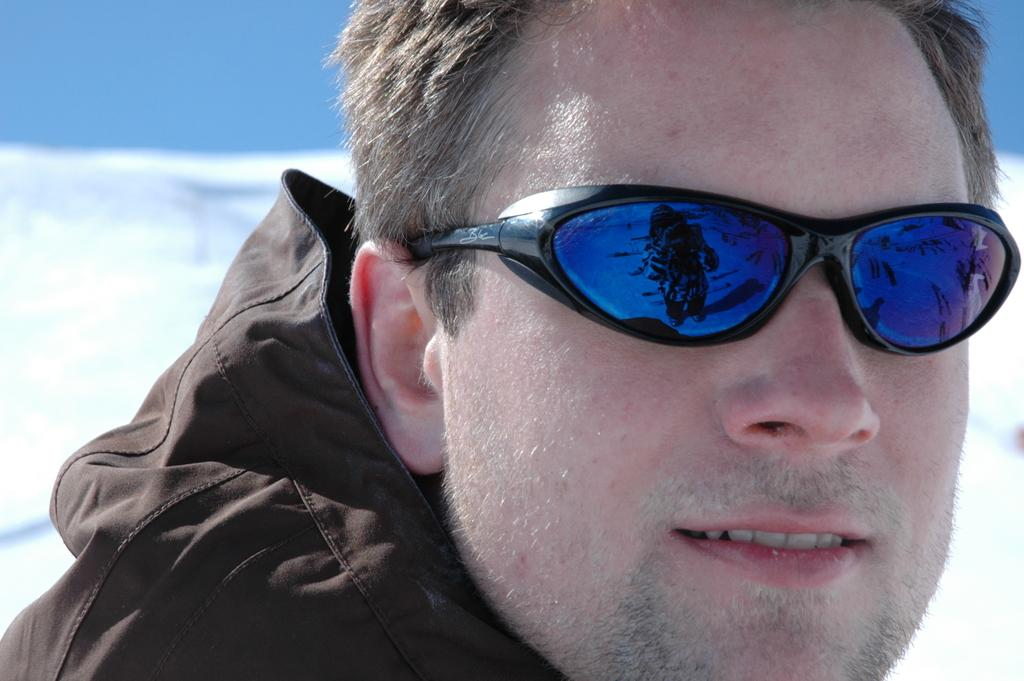What is the main subject in the foreground of the image? There is a person in the foreground of the image. What is the person wearing in the image? The person is wearing a goggle. What can be seen in the background of the image? There is ice visible in the background of the image. What is the color of the sky in the image? The sky is blue in the image. When was the image likely taken? The image was taken during the day. What type of stew is being prepared in the image? There is no stew present in the image; it features a person wearing a goggle and ice in the background. What unit of measurement is used to determine the depth of the ice in the image? There is no unit of measurement mentioned or implied in the image, as it only shows a person wearing a goggle and ice in the background. 